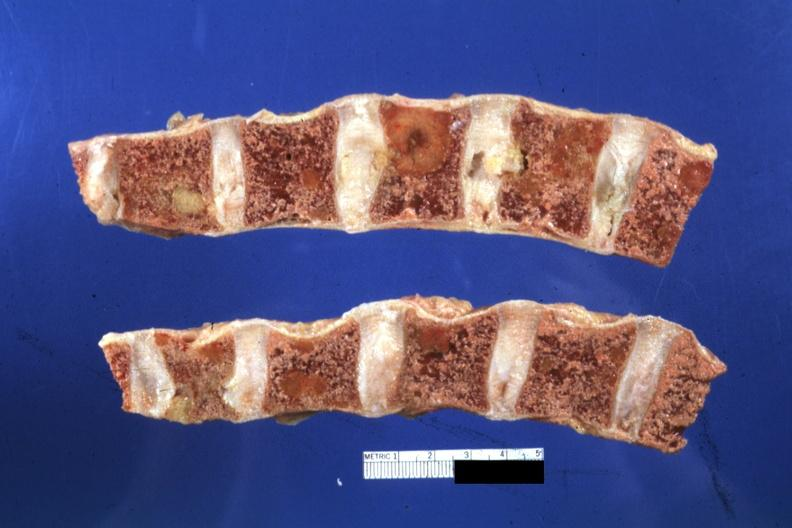what show well?
Answer the question using a single word or phrase. Fixed lesions 